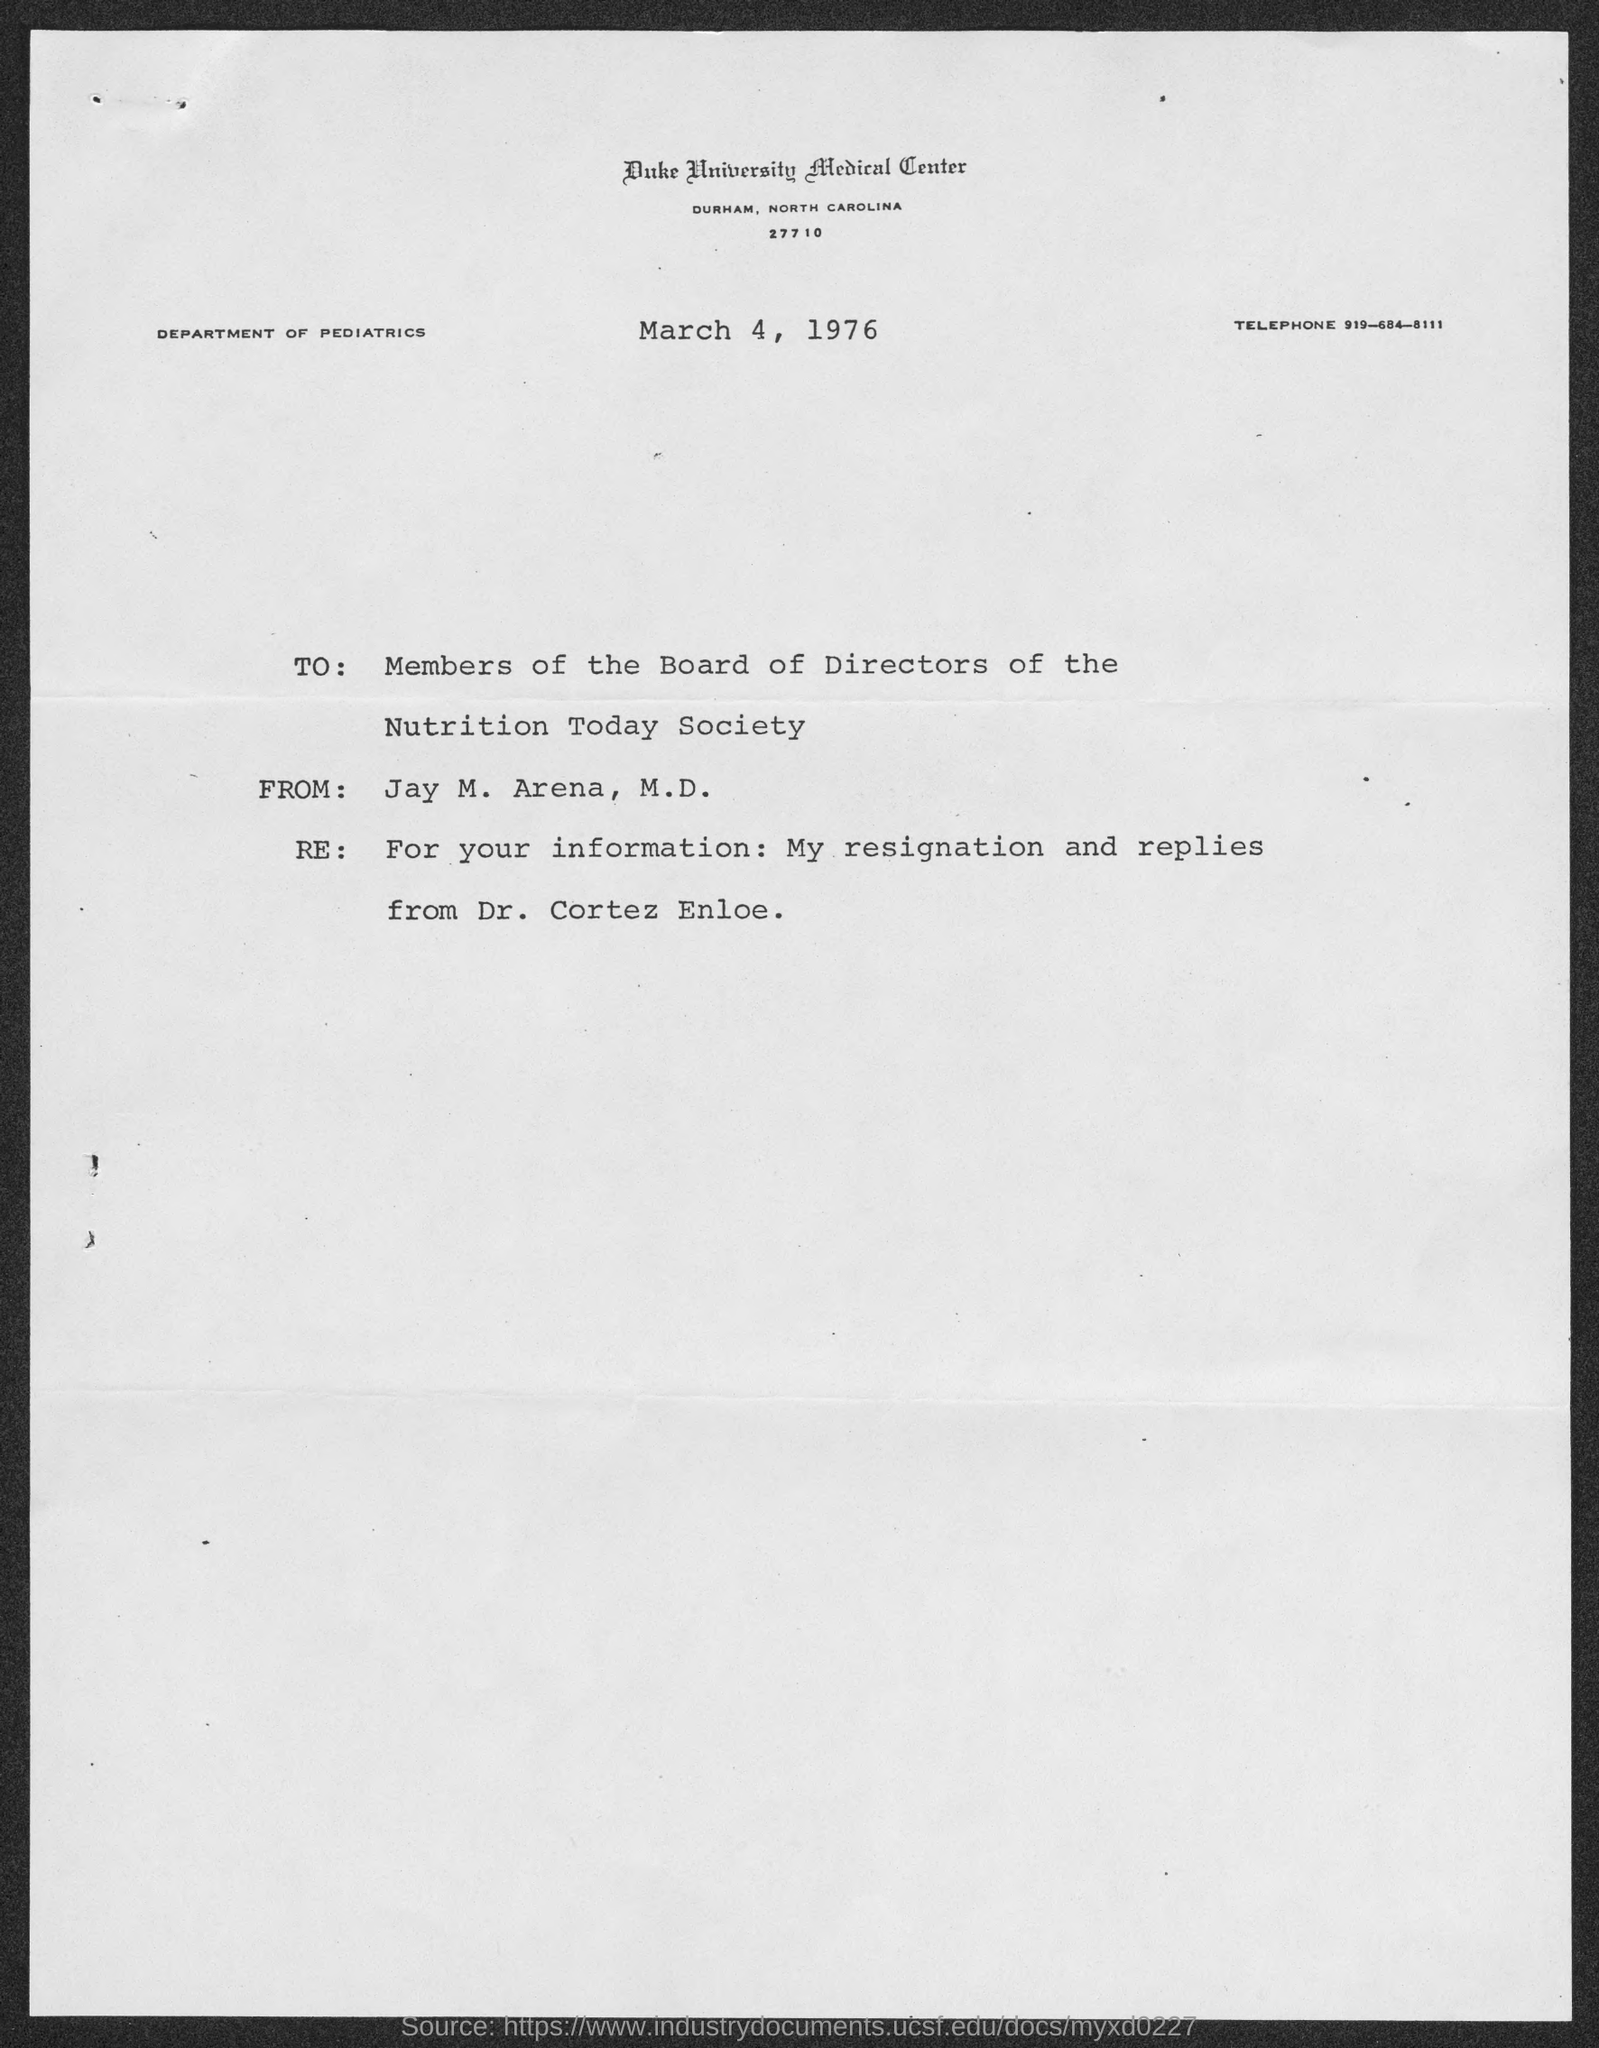Which medical center is mentioned in the header of the document?
Your response must be concise. Duke University Medical center. What is the Telephone No given in this document?
Make the answer very short. 919-684-8111. What is the date mentioned in this document?
Your answer should be very brief. March 4, 1976. Who is the sender of this document?
Your response must be concise. Jay M. Arena,  M.D. Which department is mentioned in the header of the document?
Give a very brief answer. Department of Pediatrics. 